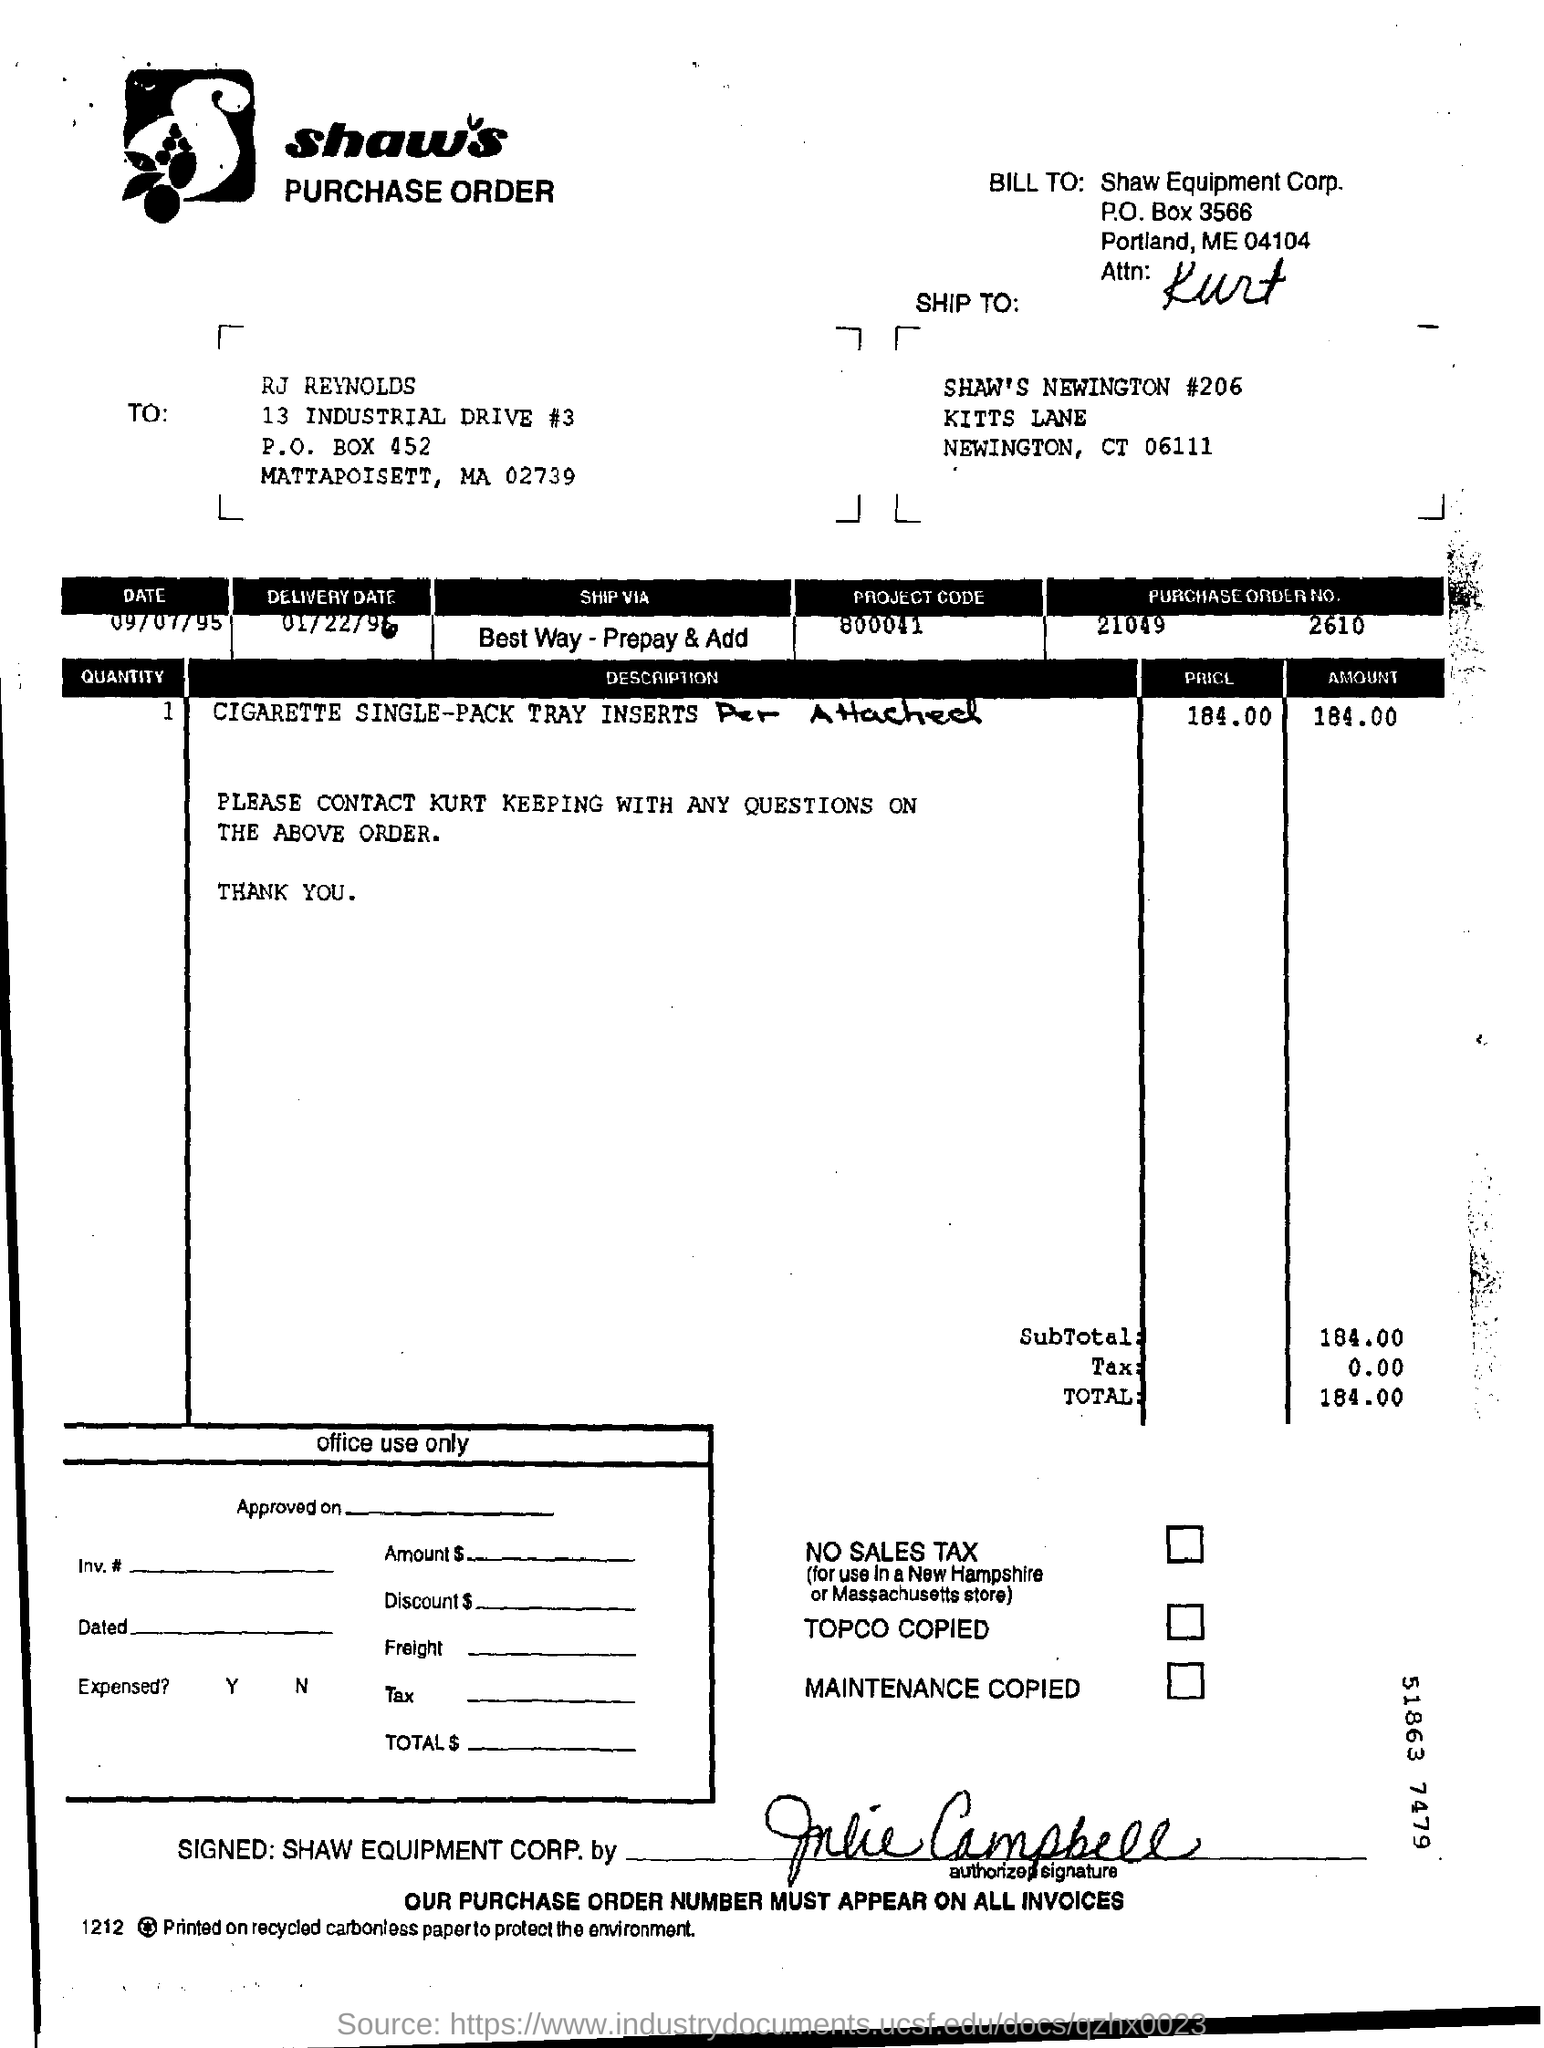Highlight a few significant elements in this photo. The delivery date is January 22, 1996. The project code is 800041. The purchase order number is 21049 2610. 